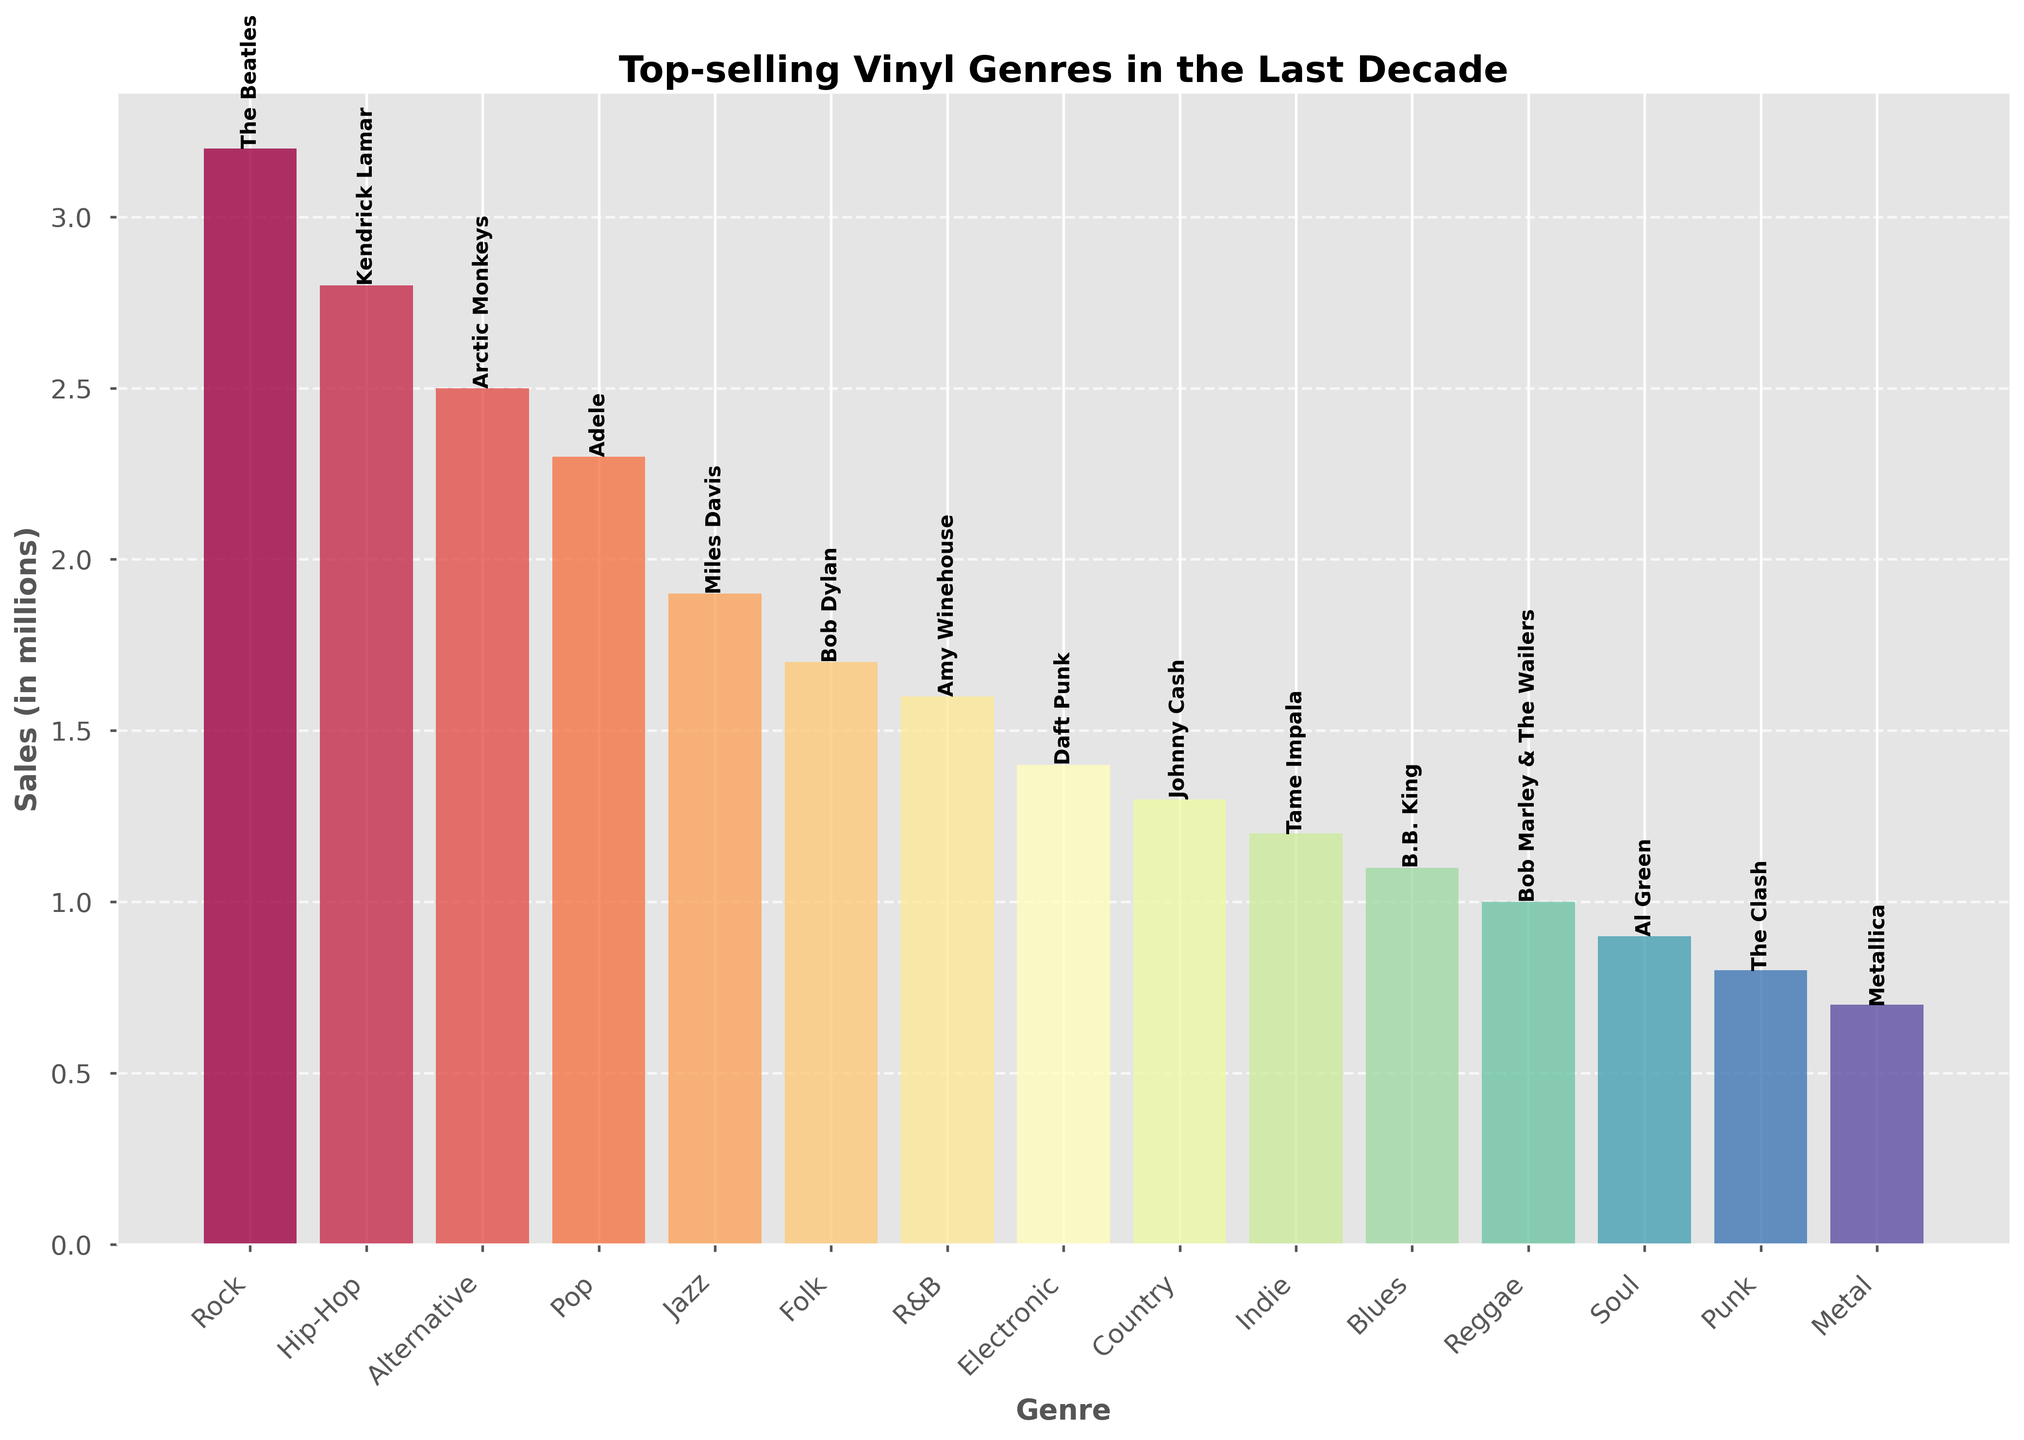How many more millions of vinyls did The Beatles sell than Metallica? First, find the sales for The Beatles (3.2 million) and Metallica (0.7 million). Then, subtract Metallica's sales from The Beatles' sales: 3.2 - 0.7 = 2.5. Thus, The Beatles sold 2.5 million more vinyls than Metallica.
Answer: 2.5 Which genre had the highest sales, and who was the top artist in that genre? Look at the bar chart and identify the genre with the tallest bar. The tallest bar corresponds to the Rock genre. The artist labeled on this bar is The Beatles.
Answer: Rock, The Beatles Which genre had the lowest sales, and who was the artist in that genre? Look for the genre with the shortest bar in the bar chart. The shortest bar represents the Metal genre, and the artist associated with it is Metallica.
Answer: Metal, Metallica What is the total sales for Jazz, Blues, and Soul combined? Identify the sales figures for Jazz (1.9 million), Blues (1.1 million), and Soul (0.9 million). Add these numbers together: 1.9 + 1.1 + 0.9 = 3.9. Thus, the total sales for these three genres combined are 3.9 million.
Answer: 3.9 Which genres had sales figures between 1.0 million and 2.0 million, and who were the corresponding artists? Identify bars with heights between 1.0 and 2.0 million. These genres and their artists are: Jazz (Miles Davis), Folk (Bob Dylan), R&B (Amy Winehouse), Electronic (Daft Punk), Country (Johnny Cash), Indie (Tame Impala), Blues (B.B. King), and Reggae (Bob Marley & The Wailers).
Answer: Jazz (Miles Davis), Folk (Bob Dylan), R&B (Amy Winehouse), Electronic (Daft Punk), Country (Johnny Cash), Indie (Tame Impala), Blues (B.B. King), Reggae (Bob Marley & The Wailers) How many more millions of vinyls did Kendrick Lamar sell compared to Arctic Monkeys? Find the sales figures for Kendrick Lamar (2.8 million) and Arctic Monkeys (2.5 million). Subtract Arctic Monkeys' sales from Kendrick Lamar's sales: 2.8 - 2.5 = 0.3. Thus, Kendrick Lamar sold 0.3 million more vinyls than Arctic Monkeys.
Answer: 0.3 Which two genres had the closest sales figures, and what are these figures? Compare the heights of the bars and look for the two bars that are visually closest in height. Jazz has 1.9 million sales, and Folk has 1.7 million. The difference is only 0.2 million, making them the closest in sales.
Answer: Jazz (1.9), Folk (1.7) What is the average sales per genre of all the listed genres? Sum all the sales values from the list: 3.2 + 2.8 + 2.5 + 2.3 + 1.9 + 1.7 + 1.6 + 1.4 + 1.3 + 1.2 + 1.1 + 1.0 + 0.9 + 0.8 + 0.7 = 24.3. There are 15 genres in total. Divide the total sales by the number of genres: 24.3 / 15 = 1.62. The average sales per genre is 1.62 million.
Answer: 1.62 What are the total combined sales for Rock, Hip-Hop, and Alternative genres? Identify the sales figures for Rock (3.2 million), Hip-Hop (2.8 million), and Alternative (2.5 million). Add these numbers together: 3.2 + 2.8 + 2.5 = 8.5. Thus, the total sales for these three genres combined are 8.5 million.
Answer: 8.5 Are there any genres with sales figures equal to 1.0 million, and if so, which genre and artist are they? Look for a bar with a height corresponding to 1.0 million sales. The genre with this sales figure is Reggae, and the artist is Bob Marley & The Wailers.
Answer: Reggae, Bob Marley & The Wailers 